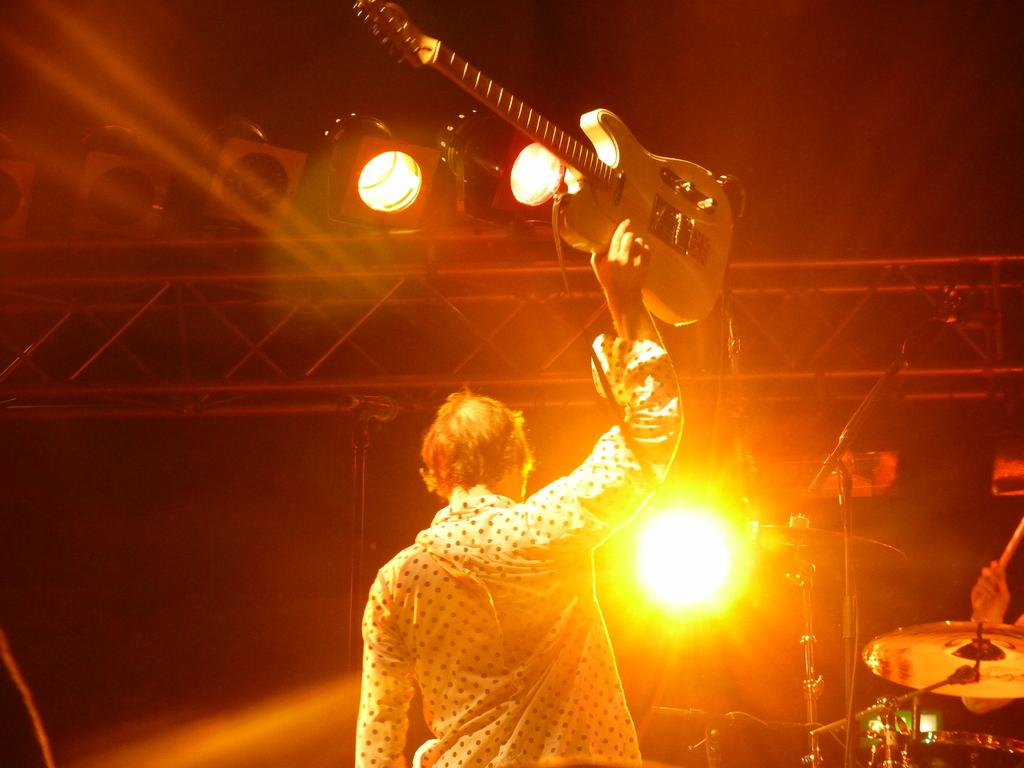What is the person in the image holding? The person in the image is holding a guitar. What type of music is being played in the image? The person is playing jazz in the image. What can be seen illuminating the scene in the image? There are lights visible in the image. What might be used for amplifying sound in the image? There are microphones (mics) in the image. What type of stand is present in the image? There is an iron stand in the image. What type of feather can be seen attached to the guitar in the image? There is no feather attached to the guitar in the image. What type of apparatus is being used to fly in the image? There is no apparatus for flying present in the image. 